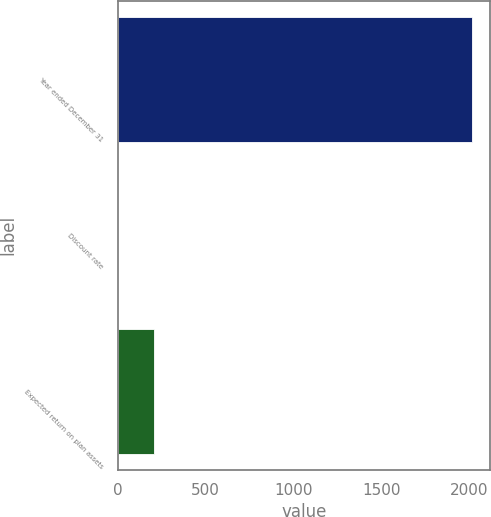<chart> <loc_0><loc_0><loc_500><loc_500><bar_chart><fcel>Year ended December 31<fcel>Discount rate<fcel>Expected return on plan assets<nl><fcel>2017<fcel>3.75<fcel>205.08<nl></chart> 